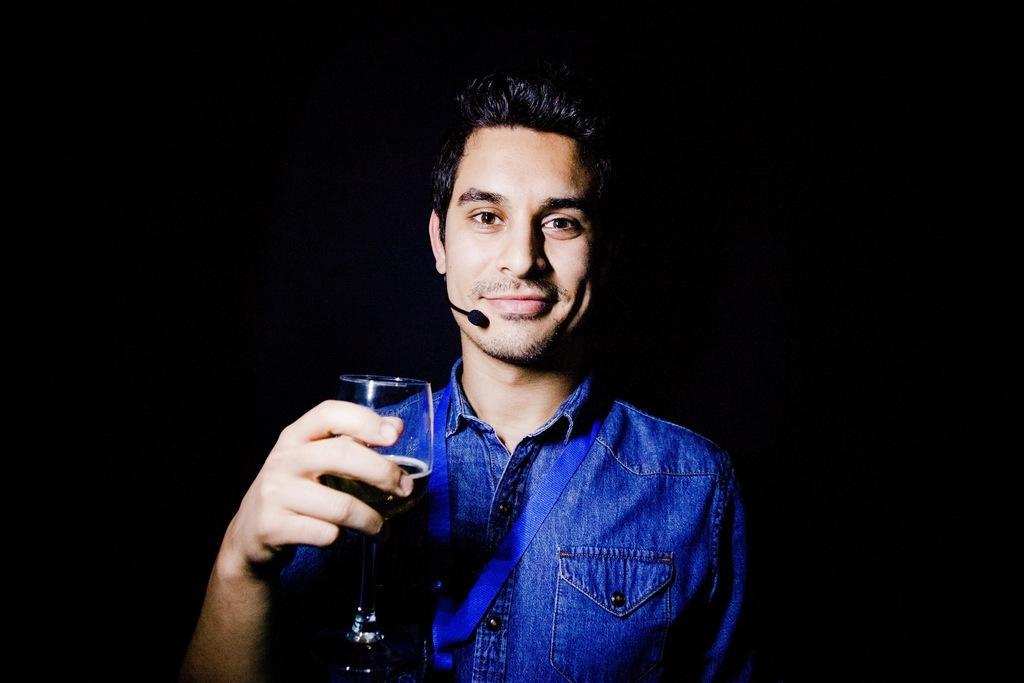Can you describe this image briefly? As we can see in the image there is a man wearing blue color shirt. He is holding a bottle and there is a mic. 